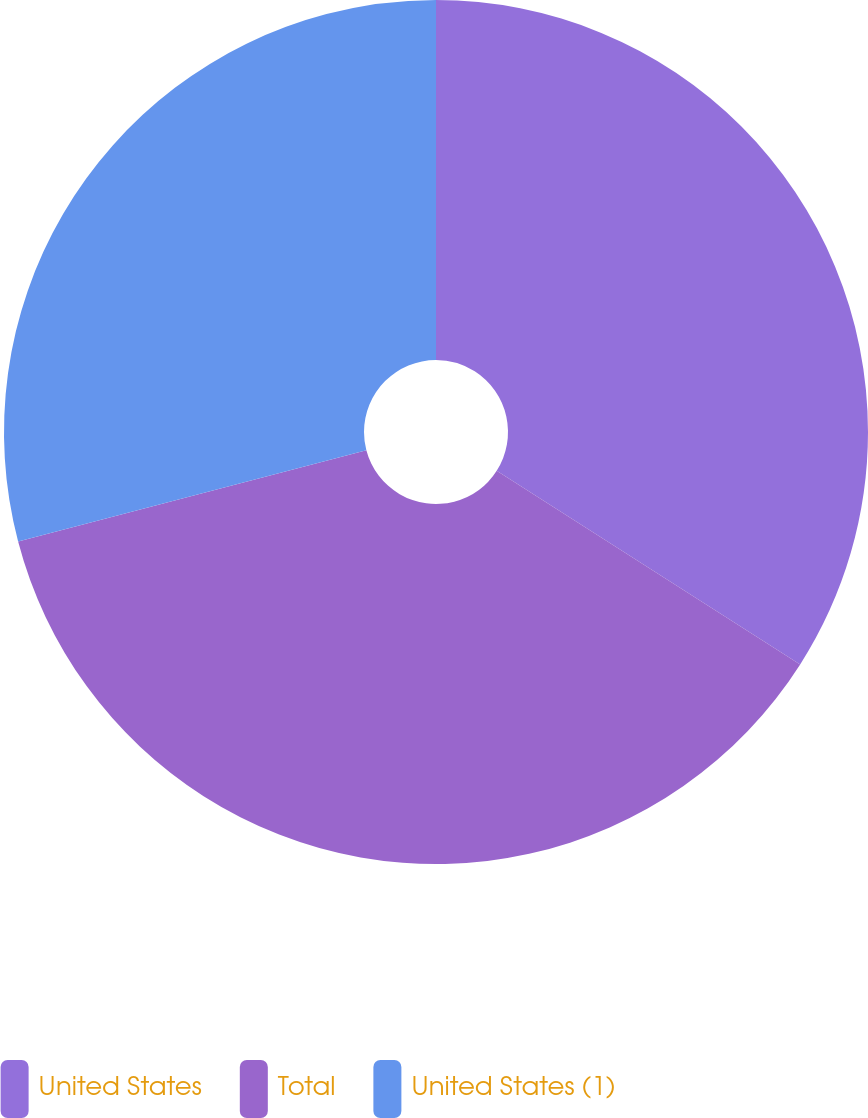Convert chart. <chart><loc_0><loc_0><loc_500><loc_500><pie_chart><fcel>United States<fcel>Total<fcel>United States (1)<nl><fcel>34.04%<fcel>36.88%<fcel>29.08%<nl></chart> 